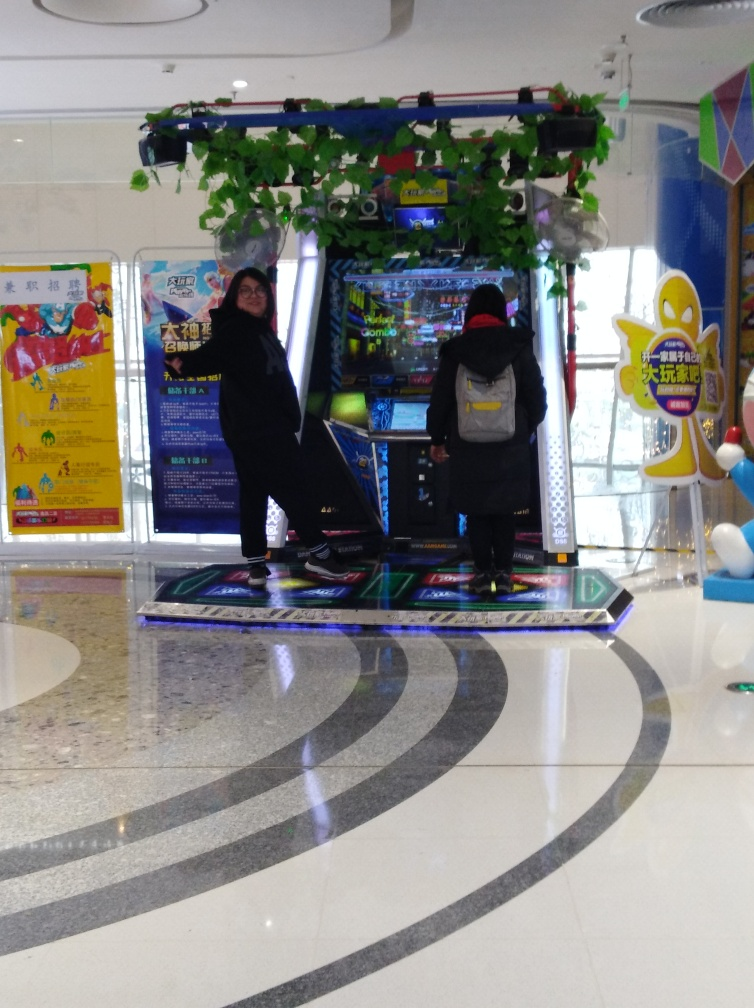Are there any quality issues with this image? The image quality appears to be slightly compromised with noticeable blur, likely due to camera movement or low shutter speed. Moreover, the lighting conditions are not optimal, casting shadows inconsistently and causing some areas to be underexposed. The composition could also be improved to better focus on the subjects. 